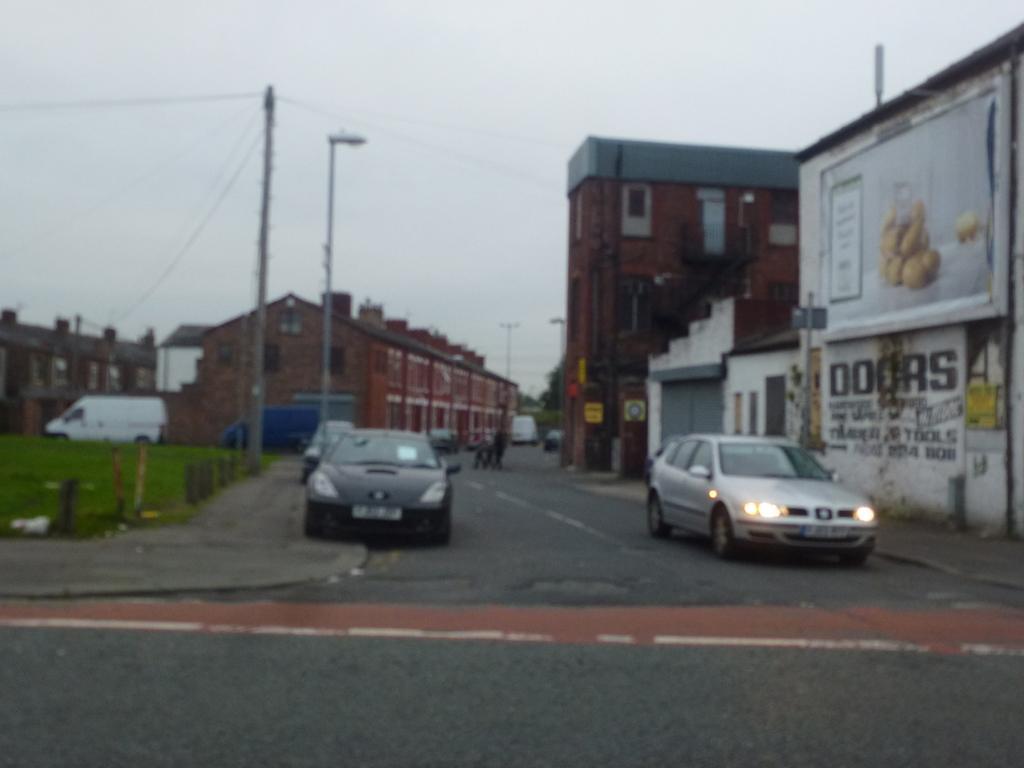Can you describe this image briefly? In this image I can see the vehicles on the road. To the side of the vehicles I can see the poles, grass and the building. In the background I can see few more buildings, trees and the sky. 